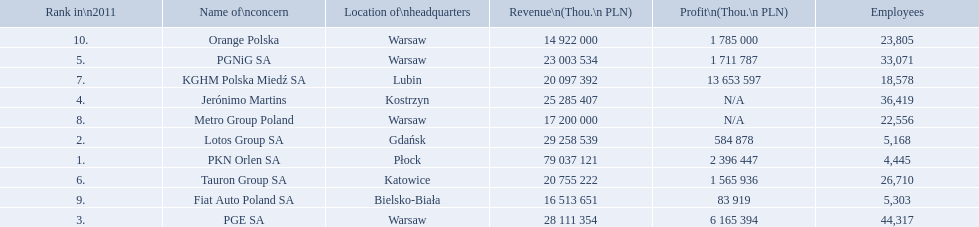What company has 28 111 354 thou.in revenue? PGE SA. What revenue does lotus group sa have? 29 258 539. Who has the next highest revenue than lotus group sa? PKN Orlen SA. 